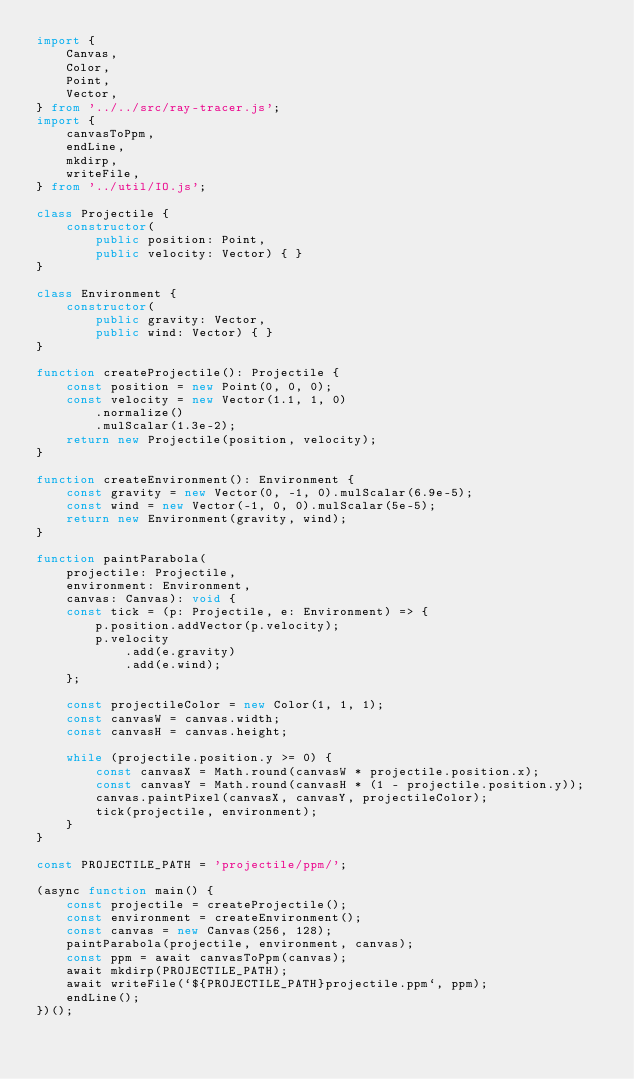<code> <loc_0><loc_0><loc_500><loc_500><_TypeScript_>import {
    Canvas,
    Color,
    Point,
    Vector,
} from '../../src/ray-tracer.js';
import {
    canvasToPpm,
    endLine,
    mkdirp,
    writeFile,
} from '../util/IO.js';

class Projectile {
    constructor(
        public position: Point,
        public velocity: Vector) { }
}

class Environment {
    constructor(
        public gravity: Vector,
        public wind: Vector) { }
}

function createProjectile(): Projectile {
    const position = new Point(0, 0, 0);
    const velocity = new Vector(1.1, 1, 0)
        .normalize()
        .mulScalar(1.3e-2);
    return new Projectile(position, velocity);
}

function createEnvironment(): Environment {
    const gravity = new Vector(0, -1, 0).mulScalar(6.9e-5);
    const wind = new Vector(-1, 0, 0).mulScalar(5e-5);
    return new Environment(gravity, wind);
}

function paintParabola(
    projectile: Projectile,
    environment: Environment,
    canvas: Canvas): void {
    const tick = (p: Projectile, e: Environment) => {
        p.position.addVector(p.velocity);
        p.velocity
            .add(e.gravity)
            .add(e.wind);
    };

    const projectileColor = new Color(1, 1, 1);
    const canvasW = canvas.width;
    const canvasH = canvas.height;

    while (projectile.position.y >= 0) {
        const canvasX = Math.round(canvasW * projectile.position.x);
        const canvasY = Math.round(canvasH * (1 - projectile.position.y));
        canvas.paintPixel(canvasX, canvasY, projectileColor);
        tick(projectile, environment);
    }
}

const PROJECTILE_PATH = 'projectile/ppm/';

(async function main() {
    const projectile = createProjectile();
    const environment = createEnvironment();
    const canvas = new Canvas(256, 128);
    paintParabola(projectile, environment, canvas);
    const ppm = await canvasToPpm(canvas);
    await mkdirp(PROJECTILE_PATH);
    await writeFile(`${PROJECTILE_PATH}projectile.ppm`, ppm);
    endLine();
})();
</code> 